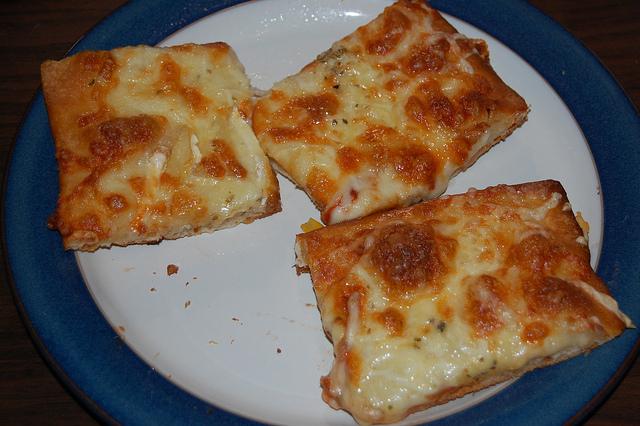What colors are on the plate?
Be succinct. White and blue. What type of food is this?
Short answer required. Pizza. Could one piece have been already eaten?
Give a very brief answer. Yes. Are both pizzas the same?
Write a very short answer. Yes. 